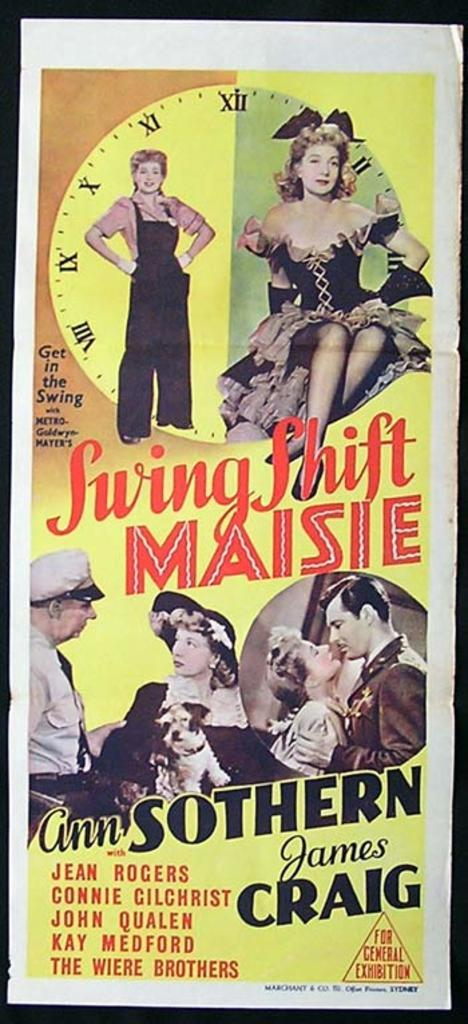<image>
Create a compact narrative representing the image presented. An old movie poster for a black and white called Saving Shift Maisie. 